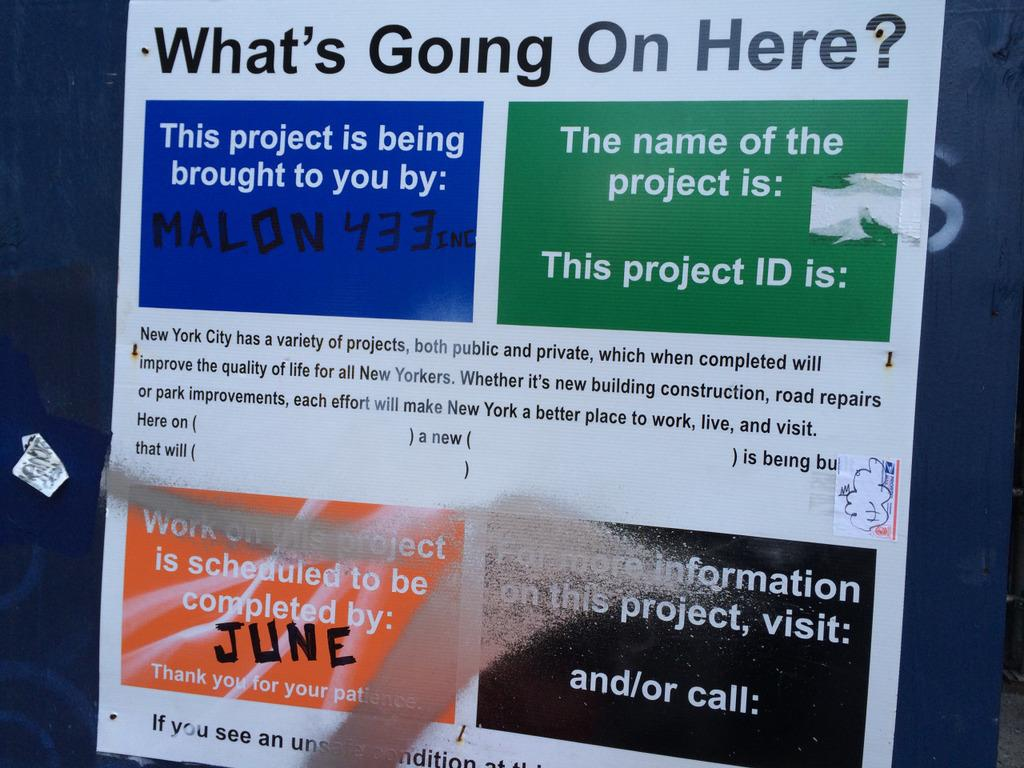<image>
Provide a brief description of the given image. a poster with What's Going on Here? written at the top with more information below that about the project. 